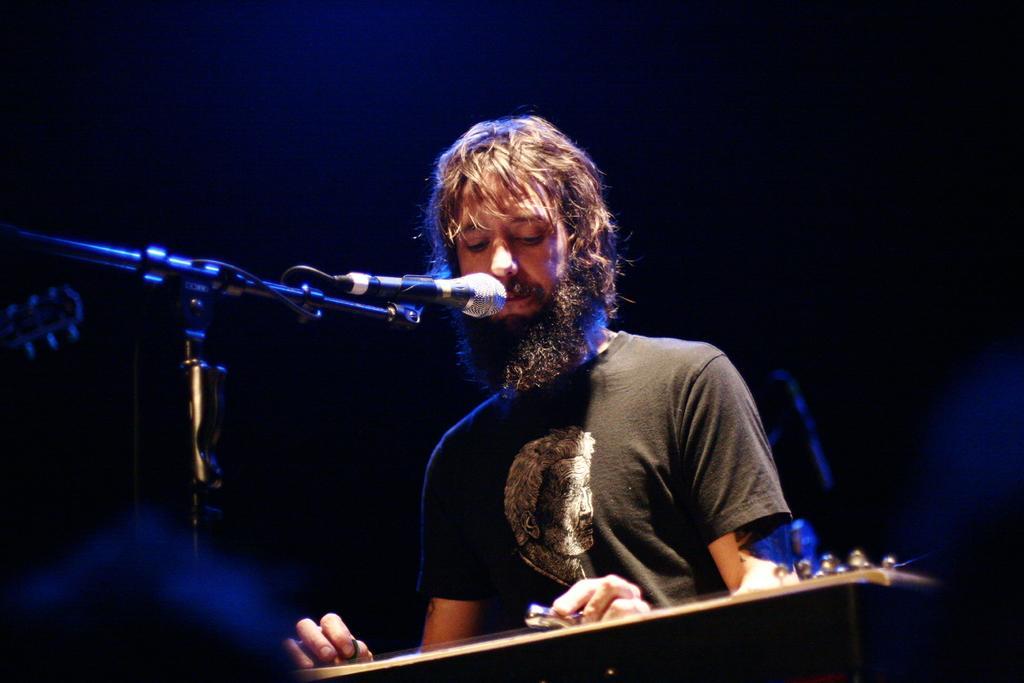Please provide a concise description of this image. In this image there is a man who is playing the guitar. In front of him there is a mic. 